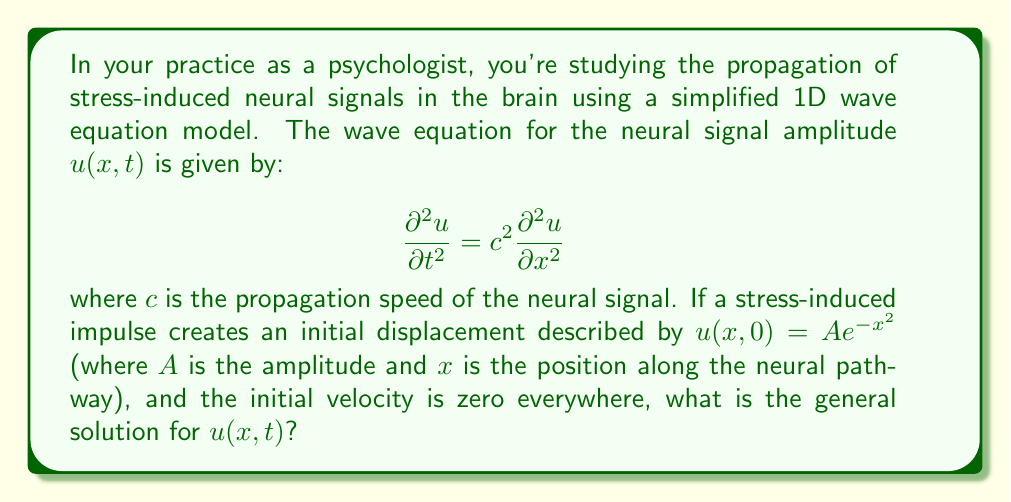Can you answer this question? To solve this problem, we'll follow these steps:

1) The general solution to the 1D wave equation is given by d'Alembert's formula:

   $$u(x,t) = \frac{1}{2}[f(x+ct) + f(x-ct)] + \frac{1}{2c}\int_{x-ct}^{x+ct} g(s) ds$$

   where $f(x)$ is the initial displacement and $g(x)$ is the initial velocity.

2) In this case, we're given:
   
   $f(x) = u(x,0) = Ae^{-x^2}$
   $g(x) = u_t(x,0) = 0$

3) Since $g(x) = 0$, the integral term in d'Alembert's formula vanishes, simplifying our solution to:

   $$u(x,t) = \frac{1}{2}[f(x+ct) + f(x-ct)]$$

4) Substituting our initial displacement function:

   $$u(x,t) = \frac{1}{2}[Ae^{-(x+ct)^2} + Ae^{-(x-ct)^2}]$$

5) Factoring out $A$:

   $$u(x,t) = \frac{A}{2}[e^{-(x+ct)^2} + e^{-(x-ct)^2}]$$

This is the general solution for $u(x,t)$ given the initial conditions.
Answer: $$u(x,t) = \frac{A}{2}[e^{-(x+ct)^2} + e^{-(x-ct)^2}]$$ 